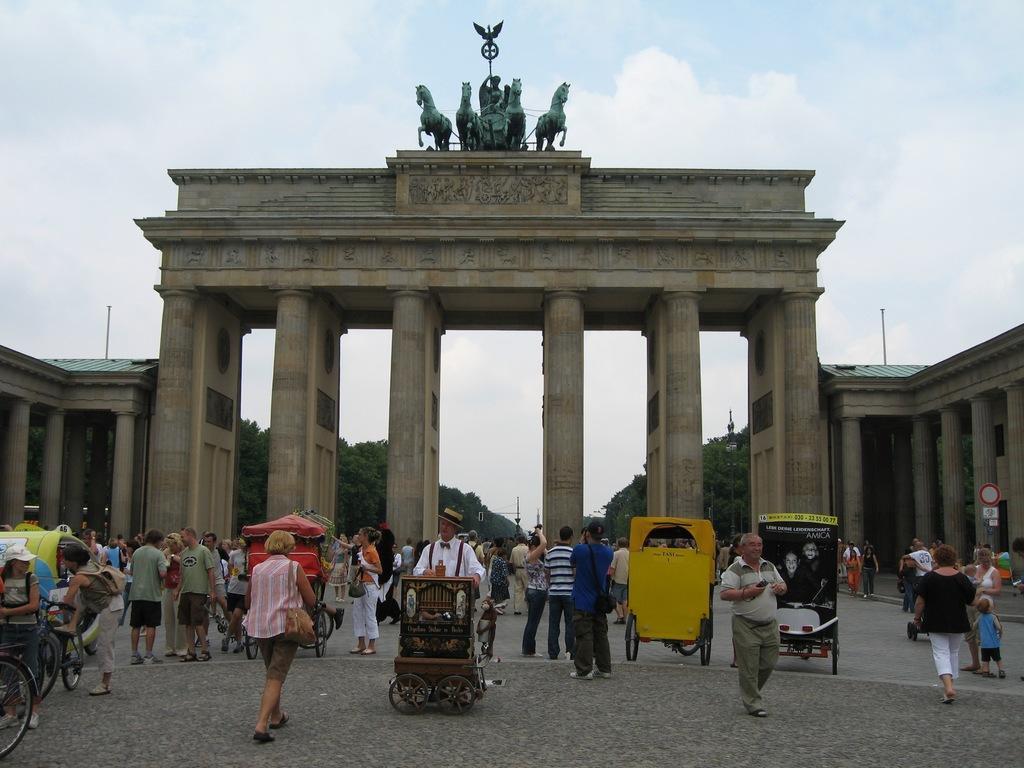Describe this image in one or two sentences. In this image we can see an arch and there are sculptures. At the bottom there are people and we can see vehicles. In the background there is sky and we can see trees and there are pillars. 